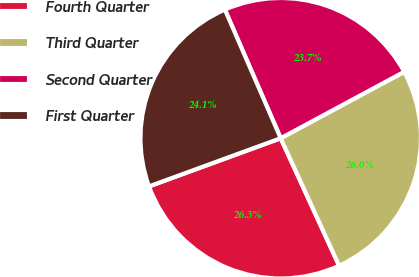<chart> <loc_0><loc_0><loc_500><loc_500><pie_chart><fcel>Fourth Quarter<fcel>Third Quarter<fcel>Second Quarter<fcel>First Quarter<nl><fcel>26.26%<fcel>26.01%<fcel>23.66%<fcel>24.06%<nl></chart> 